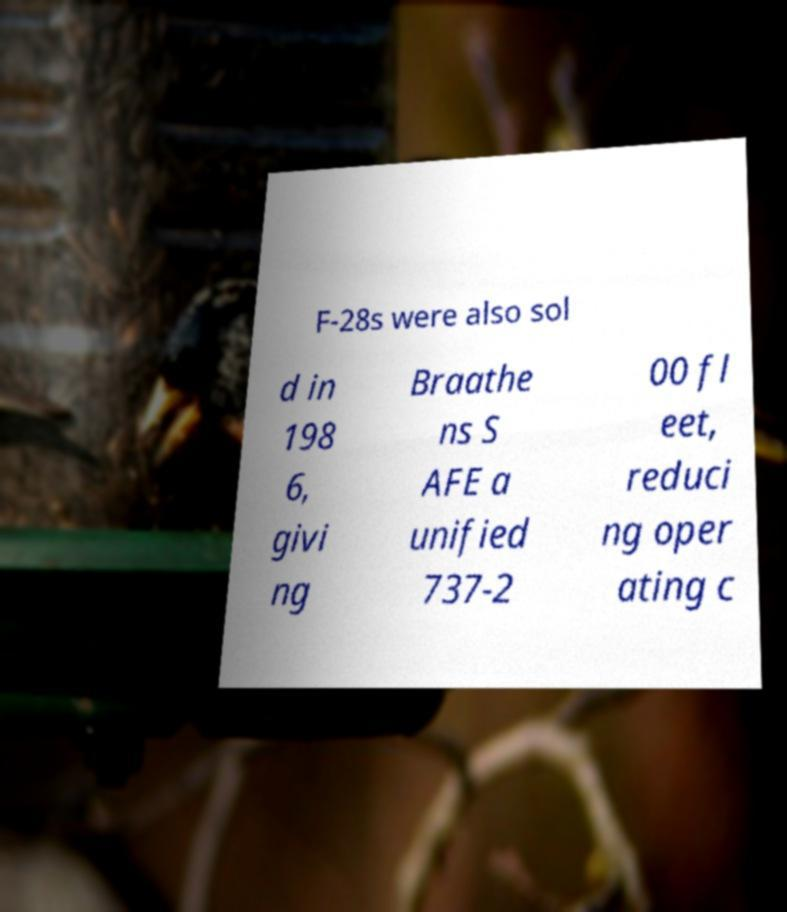What messages or text are displayed in this image? I need them in a readable, typed format. F-28s were also sol d in 198 6, givi ng Braathe ns S AFE a unified 737-2 00 fl eet, reduci ng oper ating c 